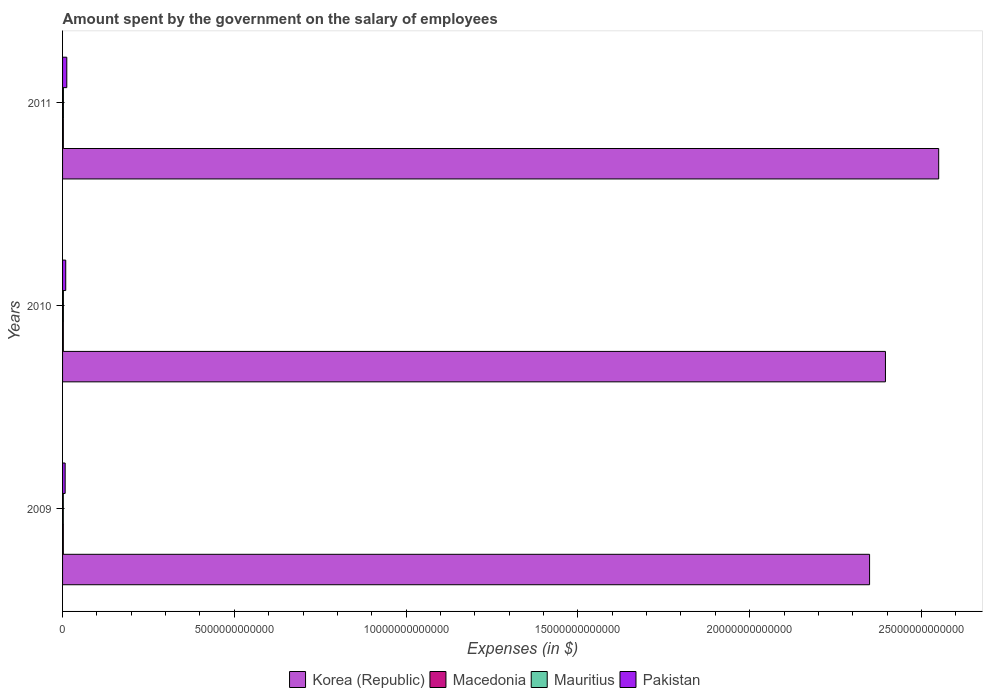How many different coloured bars are there?
Ensure brevity in your answer.  4. How many groups of bars are there?
Give a very brief answer. 3. Are the number of bars per tick equal to the number of legend labels?
Offer a terse response. Yes. Are the number of bars on each tick of the Y-axis equal?
Keep it short and to the point. Yes. How many bars are there on the 3rd tick from the top?
Your answer should be very brief. 4. How many bars are there on the 2nd tick from the bottom?
Give a very brief answer. 4. What is the label of the 3rd group of bars from the top?
Keep it short and to the point. 2009. In how many cases, is the number of bars for a given year not equal to the number of legend labels?
Keep it short and to the point. 0. What is the amount spent on the salary of employees by the government in Korea (Republic) in 2010?
Your answer should be compact. 2.40e+13. Across all years, what is the maximum amount spent on the salary of employees by the government in Korea (Republic)?
Provide a succinct answer. 2.55e+13. Across all years, what is the minimum amount spent on the salary of employees by the government in Pakistan?
Provide a short and direct response. 7.54e+1. What is the total amount spent on the salary of employees by the government in Macedonia in the graph?
Offer a very short reply. 6.85e+1. What is the difference between the amount spent on the salary of employees by the government in Pakistan in 2009 and that in 2011?
Make the answer very short. -4.77e+1. What is the difference between the amount spent on the salary of employees by the government in Macedonia in 2009 and the amount spent on the salary of employees by the government in Mauritius in 2011?
Give a very brief answer. -1.87e+09. What is the average amount spent on the salary of employees by the government in Korea (Republic) per year?
Your answer should be very brief. 2.43e+13. In the year 2009, what is the difference between the amount spent on the salary of employees by the government in Korea (Republic) and amount spent on the salary of employees by the government in Macedonia?
Ensure brevity in your answer.  2.35e+13. What is the ratio of the amount spent on the salary of employees by the government in Mauritius in 2009 to that in 2011?
Give a very brief answer. 0.89. Is the amount spent on the salary of employees by the government in Macedonia in 2009 less than that in 2011?
Make the answer very short. Yes. Is the difference between the amount spent on the salary of employees by the government in Korea (Republic) in 2010 and 2011 greater than the difference between the amount spent on the salary of employees by the government in Macedonia in 2010 and 2011?
Provide a short and direct response. No. What is the difference between the highest and the second highest amount spent on the salary of employees by the government in Macedonia?
Provide a short and direct response. 4.48e+08. What is the difference between the highest and the lowest amount spent on the salary of employees by the government in Mauritius?
Provide a succinct answer. 2.74e+09. Is the sum of the amount spent on the salary of employees by the government in Korea (Republic) in 2009 and 2010 greater than the maximum amount spent on the salary of employees by the government in Pakistan across all years?
Your answer should be compact. Yes. What does the 3rd bar from the bottom in 2009 represents?
Offer a very short reply. Mauritius. Is it the case that in every year, the sum of the amount spent on the salary of employees by the government in Macedonia and amount spent on the salary of employees by the government in Korea (Republic) is greater than the amount spent on the salary of employees by the government in Pakistan?
Your answer should be compact. Yes. How many bars are there?
Ensure brevity in your answer.  12. Are all the bars in the graph horizontal?
Give a very brief answer. Yes. How many years are there in the graph?
Your answer should be very brief. 3. What is the difference between two consecutive major ticks on the X-axis?
Make the answer very short. 5.00e+12. What is the title of the graph?
Make the answer very short. Amount spent by the government on the salary of employees. Does "Israel" appear as one of the legend labels in the graph?
Provide a short and direct response. No. What is the label or title of the X-axis?
Give a very brief answer. Expenses (in $). What is the Expenses (in $) in Korea (Republic) in 2009?
Your response must be concise. 2.35e+13. What is the Expenses (in $) in Macedonia in 2009?
Your answer should be very brief. 2.27e+1. What is the Expenses (in $) in Mauritius in 2009?
Your answer should be compact. 2.18e+1. What is the Expenses (in $) of Pakistan in 2009?
Offer a very short reply. 7.54e+1. What is the Expenses (in $) of Korea (Republic) in 2010?
Ensure brevity in your answer.  2.40e+13. What is the Expenses (in $) in Macedonia in 2010?
Ensure brevity in your answer.  2.26e+1. What is the Expenses (in $) in Mauritius in 2010?
Your answer should be compact. 2.39e+1. What is the Expenses (in $) in Pakistan in 2010?
Your answer should be very brief. 9.21e+1. What is the Expenses (in $) in Korea (Republic) in 2011?
Provide a succinct answer. 2.55e+13. What is the Expenses (in $) of Macedonia in 2011?
Offer a terse response. 2.31e+1. What is the Expenses (in $) in Mauritius in 2011?
Your response must be concise. 2.46e+1. What is the Expenses (in $) of Pakistan in 2011?
Your answer should be compact. 1.23e+11. Across all years, what is the maximum Expenses (in $) of Korea (Republic)?
Give a very brief answer. 2.55e+13. Across all years, what is the maximum Expenses (in $) of Macedonia?
Make the answer very short. 2.31e+1. Across all years, what is the maximum Expenses (in $) of Mauritius?
Keep it short and to the point. 2.46e+1. Across all years, what is the maximum Expenses (in $) in Pakistan?
Offer a terse response. 1.23e+11. Across all years, what is the minimum Expenses (in $) of Korea (Republic)?
Your response must be concise. 2.35e+13. Across all years, what is the minimum Expenses (in $) in Macedonia?
Your answer should be compact. 2.26e+1. Across all years, what is the minimum Expenses (in $) in Mauritius?
Make the answer very short. 2.18e+1. Across all years, what is the minimum Expenses (in $) in Pakistan?
Provide a succinct answer. 7.54e+1. What is the total Expenses (in $) in Korea (Republic) in the graph?
Keep it short and to the point. 7.29e+13. What is the total Expenses (in $) in Macedonia in the graph?
Give a very brief answer. 6.85e+1. What is the total Expenses (in $) of Mauritius in the graph?
Offer a very short reply. 7.03e+1. What is the total Expenses (in $) of Pakistan in the graph?
Your answer should be compact. 2.91e+11. What is the difference between the Expenses (in $) of Korea (Republic) in 2009 and that in 2010?
Your answer should be very brief. -4.62e+11. What is the difference between the Expenses (in $) of Macedonia in 2009 and that in 2010?
Your response must be concise. 6.10e+07. What is the difference between the Expenses (in $) in Mauritius in 2009 and that in 2010?
Keep it short and to the point. -2.06e+09. What is the difference between the Expenses (in $) in Pakistan in 2009 and that in 2010?
Provide a succinct answer. -1.67e+1. What is the difference between the Expenses (in $) of Korea (Republic) in 2009 and that in 2011?
Provide a short and direct response. -2.01e+12. What is the difference between the Expenses (in $) of Macedonia in 2009 and that in 2011?
Ensure brevity in your answer.  -4.48e+08. What is the difference between the Expenses (in $) of Mauritius in 2009 and that in 2011?
Your answer should be very brief. -2.74e+09. What is the difference between the Expenses (in $) in Pakistan in 2009 and that in 2011?
Your answer should be very brief. -4.77e+1. What is the difference between the Expenses (in $) in Korea (Republic) in 2010 and that in 2011?
Offer a terse response. -1.55e+12. What is the difference between the Expenses (in $) in Macedonia in 2010 and that in 2011?
Provide a succinct answer. -5.09e+08. What is the difference between the Expenses (in $) in Mauritius in 2010 and that in 2011?
Provide a succinct answer. -6.81e+08. What is the difference between the Expenses (in $) in Pakistan in 2010 and that in 2011?
Keep it short and to the point. -3.10e+1. What is the difference between the Expenses (in $) in Korea (Republic) in 2009 and the Expenses (in $) in Macedonia in 2010?
Make the answer very short. 2.35e+13. What is the difference between the Expenses (in $) in Korea (Republic) in 2009 and the Expenses (in $) in Mauritius in 2010?
Ensure brevity in your answer.  2.35e+13. What is the difference between the Expenses (in $) of Korea (Republic) in 2009 and the Expenses (in $) of Pakistan in 2010?
Offer a very short reply. 2.34e+13. What is the difference between the Expenses (in $) of Macedonia in 2009 and the Expenses (in $) of Mauritius in 2010?
Keep it short and to the point. -1.19e+09. What is the difference between the Expenses (in $) of Macedonia in 2009 and the Expenses (in $) of Pakistan in 2010?
Make the answer very short. -6.94e+1. What is the difference between the Expenses (in $) in Mauritius in 2009 and the Expenses (in $) in Pakistan in 2010?
Your answer should be compact. -7.03e+1. What is the difference between the Expenses (in $) in Korea (Republic) in 2009 and the Expenses (in $) in Macedonia in 2011?
Keep it short and to the point. 2.35e+13. What is the difference between the Expenses (in $) in Korea (Republic) in 2009 and the Expenses (in $) in Mauritius in 2011?
Your answer should be very brief. 2.35e+13. What is the difference between the Expenses (in $) of Korea (Republic) in 2009 and the Expenses (in $) of Pakistan in 2011?
Your answer should be very brief. 2.34e+13. What is the difference between the Expenses (in $) of Macedonia in 2009 and the Expenses (in $) of Mauritius in 2011?
Provide a short and direct response. -1.87e+09. What is the difference between the Expenses (in $) in Macedonia in 2009 and the Expenses (in $) in Pakistan in 2011?
Provide a short and direct response. -1.00e+11. What is the difference between the Expenses (in $) in Mauritius in 2009 and the Expenses (in $) in Pakistan in 2011?
Your answer should be compact. -1.01e+11. What is the difference between the Expenses (in $) of Korea (Republic) in 2010 and the Expenses (in $) of Macedonia in 2011?
Offer a very short reply. 2.39e+13. What is the difference between the Expenses (in $) of Korea (Republic) in 2010 and the Expenses (in $) of Mauritius in 2011?
Keep it short and to the point. 2.39e+13. What is the difference between the Expenses (in $) of Korea (Republic) in 2010 and the Expenses (in $) of Pakistan in 2011?
Ensure brevity in your answer.  2.38e+13. What is the difference between the Expenses (in $) in Macedonia in 2010 and the Expenses (in $) in Mauritius in 2011?
Your answer should be very brief. -1.93e+09. What is the difference between the Expenses (in $) in Macedonia in 2010 and the Expenses (in $) in Pakistan in 2011?
Provide a succinct answer. -1.00e+11. What is the difference between the Expenses (in $) of Mauritius in 2010 and the Expenses (in $) of Pakistan in 2011?
Offer a terse response. -9.92e+1. What is the average Expenses (in $) of Korea (Republic) per year?
Keep it short and to the point. 2.43e+13. What is the average Expenses (in $) of Macedonia per year?
Make the answer very short. 2.28e+1. What is the average Expenses (in $) of Mauritius per year?
Ensure brevity in your answer.  2.34e+1. What is the average Expenses (in $) in Pakistan per year?
Provide a short and direct response. 9.69e+1. In the year 2009, what is the difference between the Expenses (in $) in Korea (Republic) and Expenses (in $) in Macedonia?
Your answer should be compact. 2.35e+13. In the year 2009, what is the difference between the Expenses (in $) in Korea (Republic) and Expenses (in $) in Mauritius?
Your answer should be very brief. 2.35e+13. In the year 2009, what is the difference between the Expenses (in $) of Korea (Republic) and Expenses (in $) of Pakistan?
Make the answer very short. 2.34e+13. In the year 2009, what is the difference between the Expenses (in $) in Macedonia and Expenses (in $) in Mauritius?
Your answer should be very brief. 8.63e+08. In the year 2009, what is the difference between the Expenses (in $) of Macedonia and Expenses (in $) of Pakistan?
Offer a terse response. -5.27e+1. In the year 2009, what is the difference between the Expenses (in $) of Mauritius and Expenses (in $) of Pakistan?
Make the answer very short. -5.36e+1. In the year 2010, what is the difference between the Expenses (in $) in Korea (Republic) and Expenses (in $) in Macedonia?
Offer a terse response. 2.39e+13. In the year 2010, what is the difference between the Expenses (in $) of Korea (Republic) and Expenses (in $) of Mauritius?
Make the answer very short. 2.39e+13. In the year 2010, what is the difference between the Expenses (in $) of Korea (Republic) and Expenses (in $) of Pakistan?
Make the answer very short. 2.39e+13. In the year 2010, what is the difference between the Expenses (in $) of Macedonia and Expenses (in $) of Mauritius?
Your answer should be compact. -1.25e+09. In the year 2010, what is the difference between the Expenses (in $) in Macedonia and Expenses (in $) in Pakistan?
Keep it short and to the point. -6.95e+1. In the year 2010, what is the difference between the Expenses (in $) of Mauritius and Expenses (in $) of Pakistan?
Ensure brevity in your answer.  -6.82e+1. In the year 2011, what is the difference between the Expenses (in $) of Korea (Republic) and Expenses (in $) of Macedonia?
Provide a short and direct response. 2.55e+13. In the year 2011, what is the difference between the Expenses (in $) in Korea (Republic) and Expenses (in $) in Mauritius?
Give a very brief answer. 2.55e+13. In the year 2011, what is the difference between the Expenses (in $) of Korea (Republic) and Expenses (in $) of Pakistan?
Your answer should be very brief. 2.54e+13. In the year 2011, what is the difference between the Expenses (in $) of Macedonia and Expenses (in $) of Mauritius?
Your answer should be compact. -1.43e+09. In the year 2011, what is the difference between the Expenses (in $) of Macedonia and Expenses (in $) of Pakistan?
Give a very brief answer. -1.00e+11. In the year 2011, what is the difference between the Expenses (in $) of Mauritius and Expenses (in $) of Pakistan?
Ensure brevity in your answer.  -9.85e+1. What is the ratio of the Expenses (in $) in Korea (Republic) in 2009 to that in 2010?
Your answer should be very brief. 0.98. What is the ratio of the Expenses (in $) in Macedonia in 2009 to that in 2010?
Your answer should be compact. 1. What is the ratio of the Expenses (in $) in Mauritius in 2009 to that in 2010?
Offer a very short reply. 0.91. What is the ratio of the Expenses (in $) of Pakistan in 2009 to that in 2010?
Offer a very short reply. 0.82. What is the ratio of the Expenses (in $) in Korea (Republic) in 2009 to that in 2011?
Your answer should be compact. 0.92. What is the ratio of the Expenses (in $) in Macedonia in 2009 to that in 2011?
Your answer should be very brief. 0.98. What is the ratio of the Expenses (in $) in Mauritius in 2009 to that in 2011?
Offer a terse response. 0.89. What is the ratio of the Expenses (in $) of Pakistan in 2009 to that in 2011?
Your answer should be compact. 0.61. What is the ratio of the Expenses (in $) of Korea (Republic) in 2010 to that in 2011?
Offer a very short reply. 0.94. What is the ratio of the Expenses (in $) in Macedonia in 2010 to that in 2011?
Provide a short and direct response. 0.98. What is the ratio of the Expenses (in $) in Mauritius in 2010 to that in 2011?
Ensure brevity in your answer.  0.97. What is the ratio of the Expenses (in $) in Pakistan in 2010 to that in 2011?
Your answer should be compact. 0.75. What is the difference between the highest and the second highest Expenses (in $) of Korea (Republic)?
Make the answer very short. 1.55e+12. What is the difference between the highest and the second highest Expenses (in $) of Macedonia?
Your answer should be very brief. 4.48e+08. What is the difference between the highest and the second highest Expenses (in $) of Mauritius?
Offer a very short reply. 6.81e+08. What is the difference between the highest and the second highest Expenses (in $) of Pakistan?
Your answer should be compact. 3.10e+1. What is the difference between the highest and the lowest Expenses (in $) of Korea (Republic)?
Make the answer very short. 2.01e+12. What is the difference between the highest and the lowest Expenses (in $) in Macedonia?
Your answer should be very brief. 5.09e+08. What is the difference between the highest and the lowest Expenses (in $) in Mauritius?
Provide a succinct answer. 2.74e+09. What is the difference between the highest and the lowest Expenses (in $) in Pakistan?
Keep it short and to the point. 4.77e+1. 